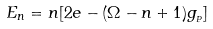<formula> <loc_0><loc_0><loc_500><loc_500>E _ { n } = n [ 2 e - ( \Omega - n + 1 ) g _ { _ { P } } ]</formula> 